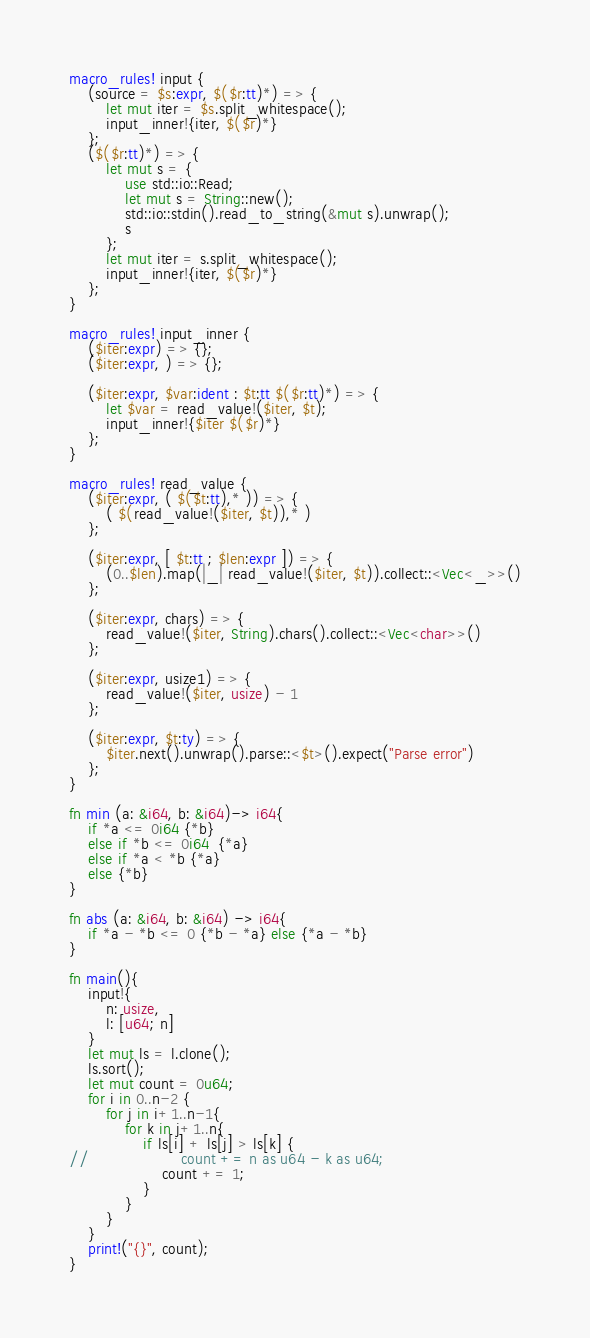<code> <loc_0><loc_0><loc_500><loc_500><_Rust_>macro_rules! input {
    (source = $s:expr, $($r:tt)*) => {
        let mut iter = $s.split_whitespace();
        input_inner!{iter, $($r)*}
    };
    ($($r:tt)*) => {
        let mut s = {
            use std::io::Read;
            let mut s = String::new();
            std::io::stdin().read_to_string(&mut s).unwrap();
            s
        };
        let mut iter = s.split_whitespace();
        input_inner!{iter, $($r)*}
    };
}

macro_rules! input_inner {
    ($iter:expr) => {};
    ($iter:expr, ) => {};

    ($iter:expr, $var:ident : $t:tt $($r:tt)*) => {
        let $var = read_value!($iter, $t);
        input_inner!{$iter $($r)*}
    };
}

macro_rules! read_value {
    ($iter:expr, ( $($t:tt),* )) => {
        ( $(read_value!($iter, $t)),* )
    };

    ($iter:expr, [ $t:tt ; $len:expr ]) => {
        (0..$len).map(|_| read_value!($iter, $t)).collect::<Vec<_>>()
    };

    ($iter:expr, chars) => {
        read_value!($iter, String).chars().collect::<Vec<char>>()
    };

    ($iter:expr, usize1) => {
        read_value!($iter, usize) - 1
    };

    ($iter:expr, $t:ty) => {
        $iter.next().unwrap().parse::<$t>().expect("Parse error")
    };
}

fn min (a: &i64, b: &i64)-> i64{
    if *a <= 0i64 {*b}
    else if *b <= 0i64  {*a}
    else if *a < *b {*a}
    else {*b}
}

fn abs (a: &i64, b: &i64) -> i64{
    if *a - *b <= 0 {*b - *a} else {*a - *b}
}

fn main(){
    input!{
        n: usize,
        l: [u64; n]
    }
    let mut ls = l.clone();
    ls.sort();
    let mut count = 0u64;
    for i in 0..n-2 {
        for j in i+1..n-1{
            for k in j+1..n{
                if ls[i] + ls[j] > ls[k] {
//                    count += n as u64 - k as u64;
                    count += 1;
                }
            }
        }
    }
    print!("{}", count);
}
</code> 